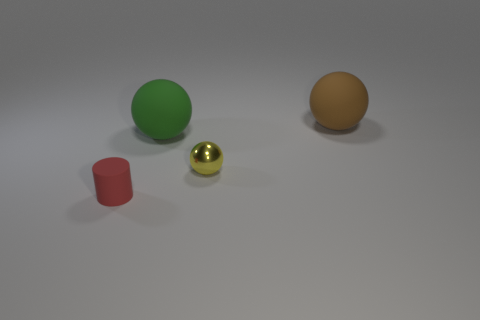Are the brown thing and the green thing made of the same material?
Make the answer very short. Yes. There is a brown rubber thing; are there any large rubber objects behind it?
Your response must be concise. No. What material is the big ball that is in front of the big matte ball that is behind the big green rubber thing?
Your answer should be compact. Rubber. There is a brown object that is the same shape as the yellow thing; what is its size?
Your answer should be compact. Large. Does the shiny thing have the same color as the matte cylinder?
Provide a short and direct response. No. What is the color of the matte thing that is right of the cylinder and on the left side of the big brown rubber thing?
Give a very brief answer. Green. Do the sphere to the left of the shiny object and the metallic ball have the same size?
Give a very brief answer. No. Are there any other things that are the same shape as the shiny object?
Make the answer very short. Yes. Do the yellow sphere and the big thing on the left side of the big brown matte object have the same material?
Your response must be concise. No. What number of green things are either cylinders or matte balls?
Give a very brief answer. 1. 